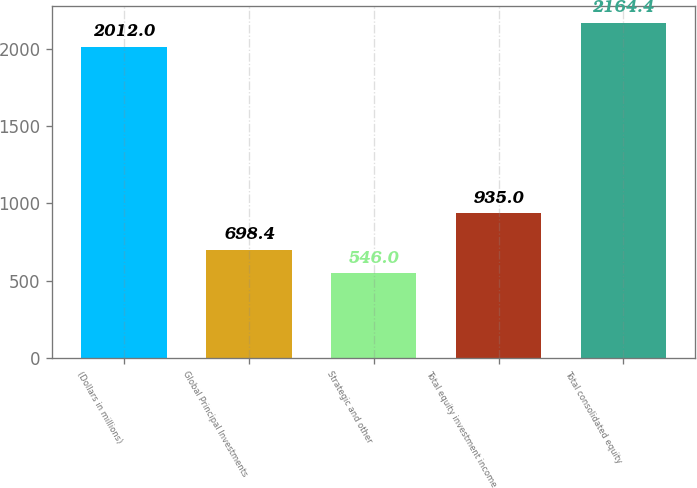Convert chart to OTSL. <chart><loc_0><loc_0><loc_500><loc_500><bar_chart><fcel>(Dollars in millions)<fcel>Global Principal Investments<fcel>Strategic and other<fcel>Total equity investment income<fcel>Total consolidated equity<nl><fcel>2012<fcel>698.4<fcel>546<fcel>935<fcel>2164.4<nl></chart> 